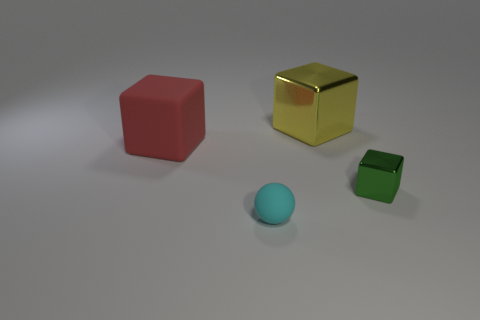Is the number of metal objects that are left of the tiny metallic thing less than the number of red rubber things?
Offer a very short reply. No. The matte object behind the matte object in front of the rubber object behind the matte ball is what color?
Provide a succinct answer. Red. Is there any other thing that is the same material as the small cyan ball?
Offer a terse response. Yes. There is a green object that is the same shape as the red matte thing; what is its size?
Offer a very short reply. Small. Is the number of tiny rubber things left of the large red matte block less than the number of large shiny things that are on the left side of the yellow cube?
Make the answer very short. No. What is the shape of the thing that is in front of the big red matte block and behind the small matte sphere?
Your answer should be compact. Cube. What is the size of the red block that is made of the same material as the cyan thing?
Your response must be concise. Large. There is a small matte sphere; is its color the same as the large object right of the large matte block?
Make the answer very short. No. What is the object that is behind the matte sphere and left of the large yellow metallic thing made of?
Offer a terse response. Rubber. There is a large thing that is on the left side of the yellow object; is its shape the same as the tiny thing to the right of the small cyan rubber object?
Provide a succinct answer. Yes. 